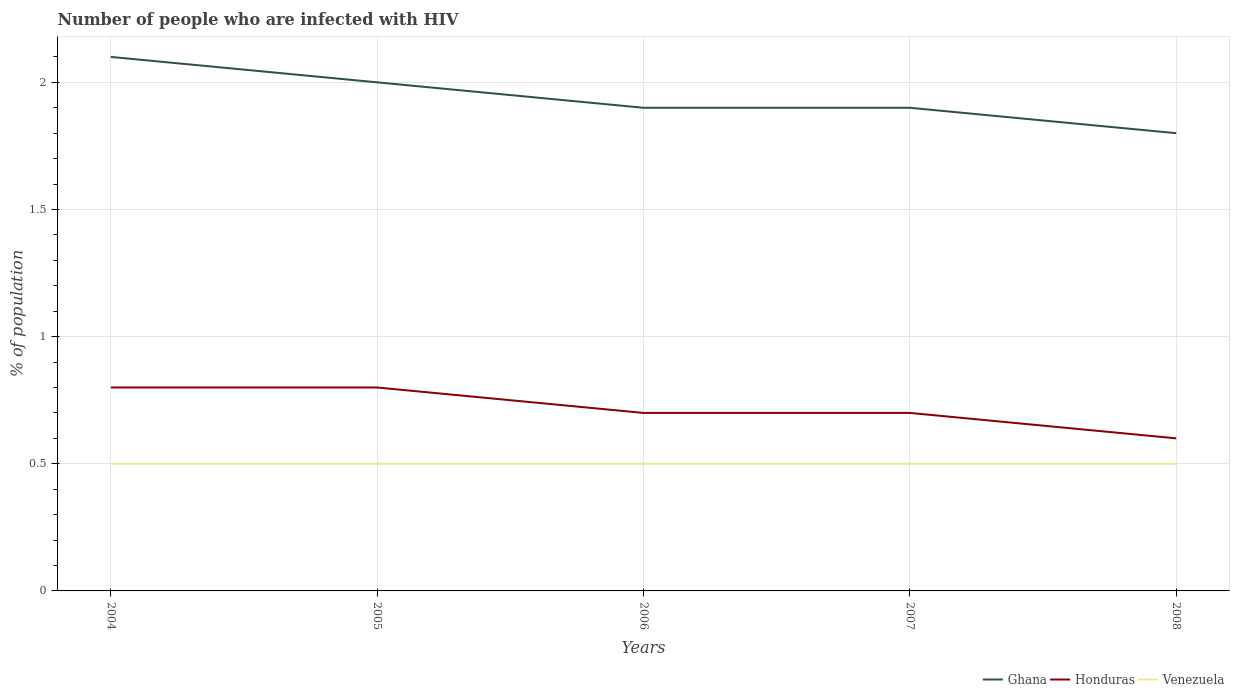In which year was the percentage of HIV infected population in in Venezuela maximum?
Keep it short and to the point. 2004. What is the total percentage of HIV infected population in in Honduras in the graph?
Give a very brief answer. 0.1. What is the difference between the highest and the second highest percentage of HIV infected population in in Venezuela?
Your answer should be very brief. 0. What is the difference between the highest and the lowest percentage of HIV infected population in in Venezuela?
Ensure brevity in your answer.  0. How many years are there in the graph?
Ensure brevity in your answer.  5. Does the graph contain grids?
Your answer should be compact. Yes. Where does the legend appear in the graph?
Your answer should be very brief. Bottom right. How many legend labels are there?
Offer a terse response. 3. What is the title of the graph?
Offer a very short reply. Number of people who are infected with HIV. What is the label or title of the X-axis?
Offer a very short reply. Years. What is the label or title of the Y-axis?
Your response must be concise. % of population. What is the % of population in Ghana in 2004?
Make the answer very short. 2.1. What is the % of population of Honduras in 2004?
Provide a short and direct response. 0.8. What is the % of population of Venezuela in 2005?
Ensure brevity in your answer.  0.5. What is the % of population of Honduras in 2006?
Provide a succinct answer. 0.7. What is the % of population of Venezuela in 2006?
Offer a very short reply. 0.5. What is the % of population of Honduras in 2007?
Your answer should be very brief. 0.7. What is the % of population of Venezuela in 2007?
Your answer should be very brief. 0.5. What is the % of population in Honduras in 2008?
Offer a very short reply. 0.6. Across all years, what is the maximum % of population in Ghana?
Ensure brevity in your answer.  2.1. Across all years, what is the maximum % of population of Honduras?
Your answer should be very brief. 0.8. Across all years, what is the minimum % of population in Ghana?
Provide a succinct answer. 1.8. Across all years, what is the minimum % of population in Honduras?
Your response must be concise. 0.6. Across all years, what is the minimum % of population in Venezuela?
Offer a very short reply. 0.5. What is the total % of population of Honduras in the graph?
Ensure brevity in your answer.  3.6. What is the total % of population of Venezuela in the graph?
Provide a short and direct response. 2.5. What is the difference between the % of population of Ghana in 2004 and that in 2005?
Give a very brief answer. 0.1. What is the difference between the % of population in Honduras in 2004 and that in 2005?
Your answer should be very brief. 0. What is the difference between the % of population of Venezuela in 2004 and that in 2005?
Provide a succinct answer. 0. What is the difference between the % of population of Ghana in 2004 and that in 2006?
Keep it short and to the point. 0.2. What is the difference between the % of population in Ghana in 2004 and that in 2007?
Provide a short and direct response. 0.2. What is the difference between the % of population in Ghana in 2004 and that in 2008?
Keep it short and to the point. 0.3. What is the difference between the % of population in Venezuela in 2004 and that in 2008?
Give a very brief answer. 0. What is the difference between the % of population in Venezuela in 2005 and that in 2006?
Offer a terse response. 0. What is the difference between the % of population of Ghana in 2005 and that in 2007?
Offer a very short reply. 0.1. What is the difference between the % of population of Honduras in 2005 and that in 2007?
Your answer should be very brief. 0.1. What is the difference between the % of population in Ghana in 2005 and that in 2008?
Your answer should be compact. 0.2. What is the difference between the % of population of Honduras in 2005 and that in 2008?
Your response must be concise. 0.2. What is the difference between the % of population of Venezuela in 2005 and that in 2008?
Give a very brief answer. 0. What is the difference between the % of population of Honduras in 2006 and that in 2007?
Give a very brief answer. 0. What is the difference between the % of population in Ghana in 2004 and the % of population in Venezuela in 2005?
Provide a succinct answer. 1.6. What is the difference between the % of population of Ghana in 2004 and the % of population of Venezuela in 2006?
Provide a short and direct response. 1.6. What is the difference between the % of population in Honduras in 2004 and the % of population in Venezuela in 2006?
Make the answer very short. 0.3. What is the difference between the % of population in Ghana in 2004 and the % of population in Honduras in 2007?
Your answer should be compact. 1.4. What is the difference between the % of population of Honduras in 2004 and the % of population of Venezuela in 2007?
Keep it short and to the point. 0.3. What is the difference between the % of population of Ghana in 2004 and the % of population of Venezuela in 2008?
Your answer should be compact. 1.6. What is the difference between the % of population of Ghana in 2005 and the % of population of Honduras in 2006?
Your response must be concise. 1.3. What is the difference between the % of population in Ghana in 2005 and the % of population in Venezuela in 2006?
Offer a terse response. 1.5. What is the difference between the % of population in Ghana in 2005 and the % of population in Honduras in 2007?
Make the answer very short. 1.3. What is the difference between the % of population in Ghana in 2005 and the % of population in Honduras in 2008?
Your response must be concise. 1.4. What is the difference between the % of population of Ghana in 2005 and the % of population of Venezuela in 2008?
Provide a succinct answer. 1.5. What is the difference between the % of population in Ghana in 2006 and the % of population in Venezuela in 2007?
Ensure brevity in your answer.  1.4. What is the difference between the % of population in Ghana in 2006 and the % of population in Honduras in 2008?
Ensure brevity in your answer.  1.3. What is the difference between the % of population in Honduras in 2006 and the % of population in Venezuela in 2008?
Offer a terse response. 0.2. What is the difference between the % of population of Ghana in 2007 and the % of population of Honduras in 2008?
Provide a short and direct response. 1.3. What is the difference between the % of population in Ghana in 2007 and the % of population in Venezuela in 2008?
Your response must be concise. 1.4. What is the difference between the % of population of Honduras in 2007 and the % of population of Venezuela in 2008?
Give a very brief answer. 0.2. What is the average % of population of Ghana per year?
Your answer should be very brief. 1.94. What is the average % of population of Honduras per year?
Keep it short and to the point. 0.72. What is the average % of population of Venezuela per year?
Offer a terse response. 0.5. In the year 2004, what is the difference between the % of population in Ghana and % of population in Honduras?
Your response must be concise. 1.3. In the year 2005, what is the difference between the % of population in Ghana and % of population in Venezuela?
Keep it short and to the point. 1.5. In the year 2006, what is the difference between the % of population in Ghana and % of population in Honduras?
Ensure brevity in your answer.  1.2. In the year 2006, what is the difference between the % of population in Ghana and % of population in Venezuela?
Your answer should be very brief. 1.4. In the year 2007, what is the difference between the % of population in Ghana and % of population in Honduras?
Your response must be concise. 1.2. In the year 2007, what is the difference between the % of population in Honduras and % of population in Venezuela?
Give a very brief answer. 0.2. In the year 2008, what is the difference between the % of population in Ghana and % of population in Venezuela?
Provide a short and direct response. 1.3. In the year 2008, what is the difference between the % of population in Honduras and % of population in Venezuela?
Provide a succinct answer. 0.1. What is the ratio of the % of population of Ghana in 2004 to that in 2006?
Keep it short and to the point. 1.11. What is the ratio of the % of population of Venezuela in 2004 to that in 2006?
Give a very brief answer. 1. What is the ratio of the % of population in Ghana in 2004 to that in 2007?
Your answer should be compact. 1.11. What is the ratio of the % of population in Honduras in 2004 to that in 2007?
Your answer should be compact. 1.14. What is the ratio of the % of population of Venezuela in 2004 to that in 2007?
Offer a terse response. 1. What is the ratio of the % of population in Ghana in 2004 to that in 2008?
Offer a terse response. 1.17. What is the ratio of the % of population of Venezuela in 2004 to that in 2008?
Keep it short and to the point. 1. What is the ratio of the % of population of Ghana in 2005 to that in 2006?
Provide a succinct answer. 1.05. What is the ratio of the % of population of Ghana in 2005 to that in 2007?
Your answer should be very brief. 1.05. What is the ratio of the % of population of Honduras in 2005 to that in 2007?
Provide a short and direct response. 1.14. What is the ratio of the % of population of Venezuela in 2005 to that in 2007?
Your answer should be very brief. 1. What is the ratio of the % of population of Honduras in 2005 to that in 2008?
Offer a terse response. 1.33. What is the ratio of the % of population of Venezuela in 2006 to that in 2007?
Offer a terse response. 1. What is the ratio of the % of population of Ghana in 2006 to that in 2008?
Provide a short and direct response. 1.06. What is the ratio of the % of population in Honduras in 2006 to that in 2008?
Keep it short and to the point. 1.17. What is the ratio of the % of population of Venezuela in 2006 to that in 2008?
Your answer should be compact. 1. What is the ratio of the % of population of Ghana in 2007 to that in 2008?
Your answer should be very brief. 1.06. What is the ratio of the % of population of Venezuela in 2007 to that in 2008?
Make the answer very short. 1. What is the difference between the highest and the lowest % of population of Honduras?
Offer a very short reply. 0.2. What is the difference between the highest and the lowest % of population of Venezuela?
Provide a succinct answer. 0. 